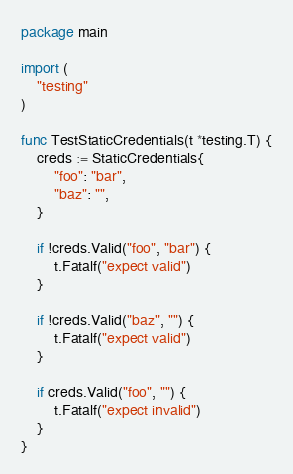Convert code to text. <code><loc_0><loc_0><loc_500><loc_500><_Go_>package main

import (
	"testing"
)

func TestStaticCredentials(t *testing.T) {
	creds := StaticCredentials{
		"foo": "bar",
		"baz": "",
	}

	if !creds.Valid("foo", "bar") {
		t.Fatalf("expect valid")
	}

	if !creds.Valid("baz", "") {
		t.Fatalf("expect valid")
	}

	if creds.Valid("foo", "") {
		t.Fatalf("expect invalid")
	}
}
</code> 